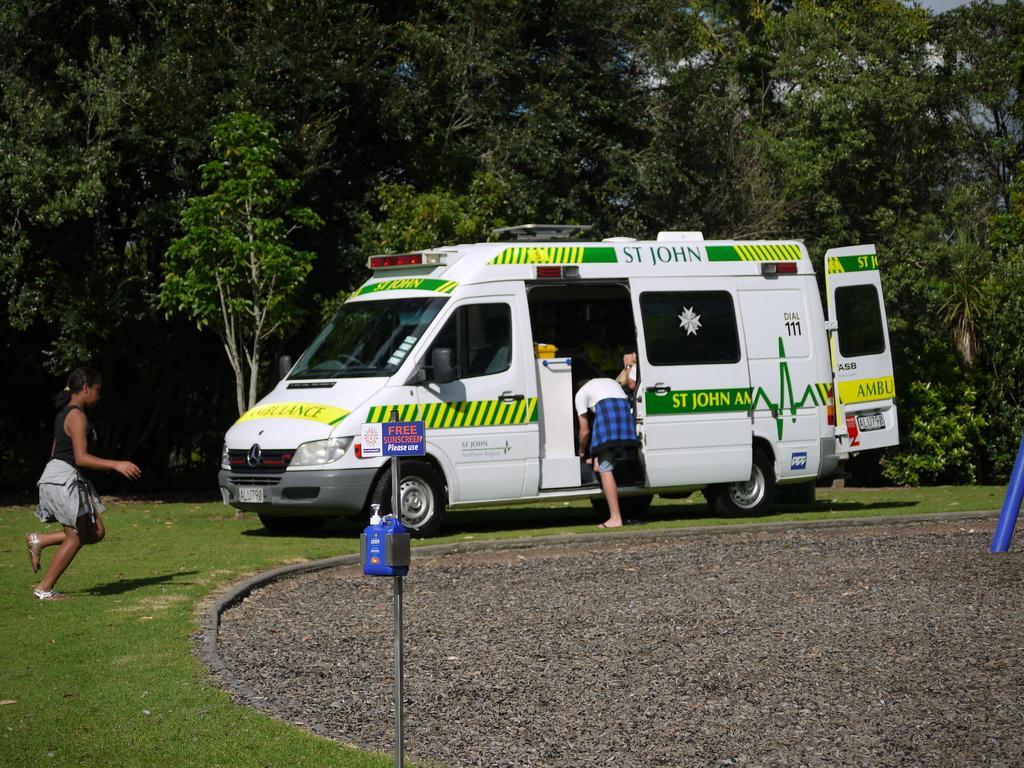How would you summarize this image in a sentence or two? In this image there is a van in a ground, on the left side there is a women, in the background there are trees. 